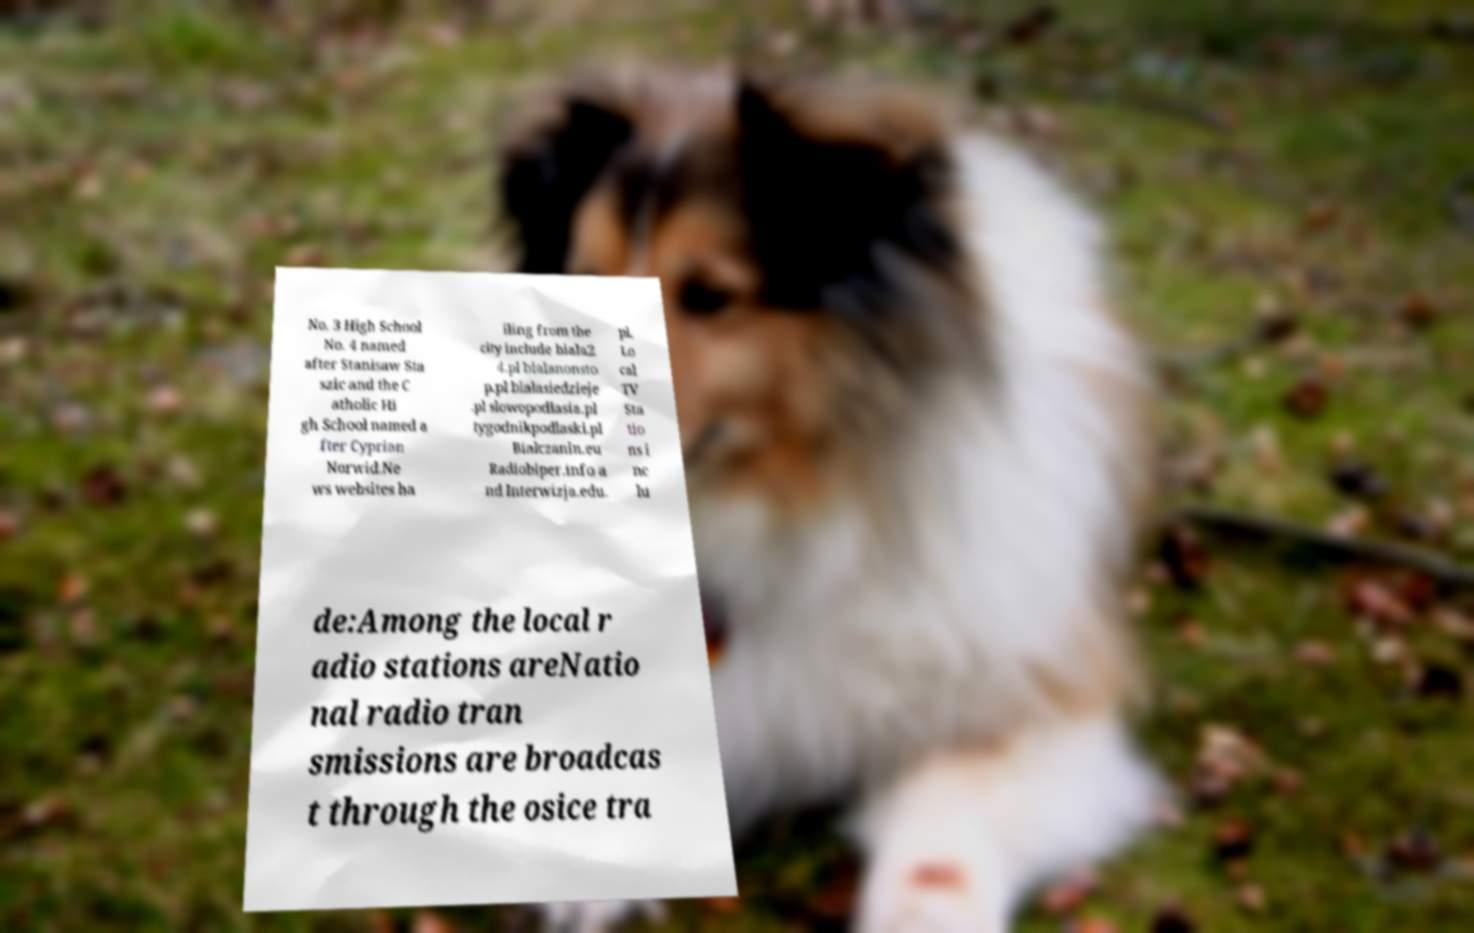Can you read and provide the text displayed in the image?This photo seems to have some interesting text. Can you extract and type it out for me? No. 3 High School No. 4 named after Stanisaw Sta szic and the C atholic Hi gh School named a fter Cyprian Norwid.Ne ws websites ha iling from the city include biala2 4.pl bialanonsto p.pl bialasiedzieje .pl slowopodlasia.pl tygodnikpodlaski.pl Bialczanin.eu Radiobiper.info a nd Interwizja.edu. pl. Lo cal TV Sta tio ns i nc lu de:Among the local r adio stations areNatio nal radio tran smissions are broadcas t through the osice tra 